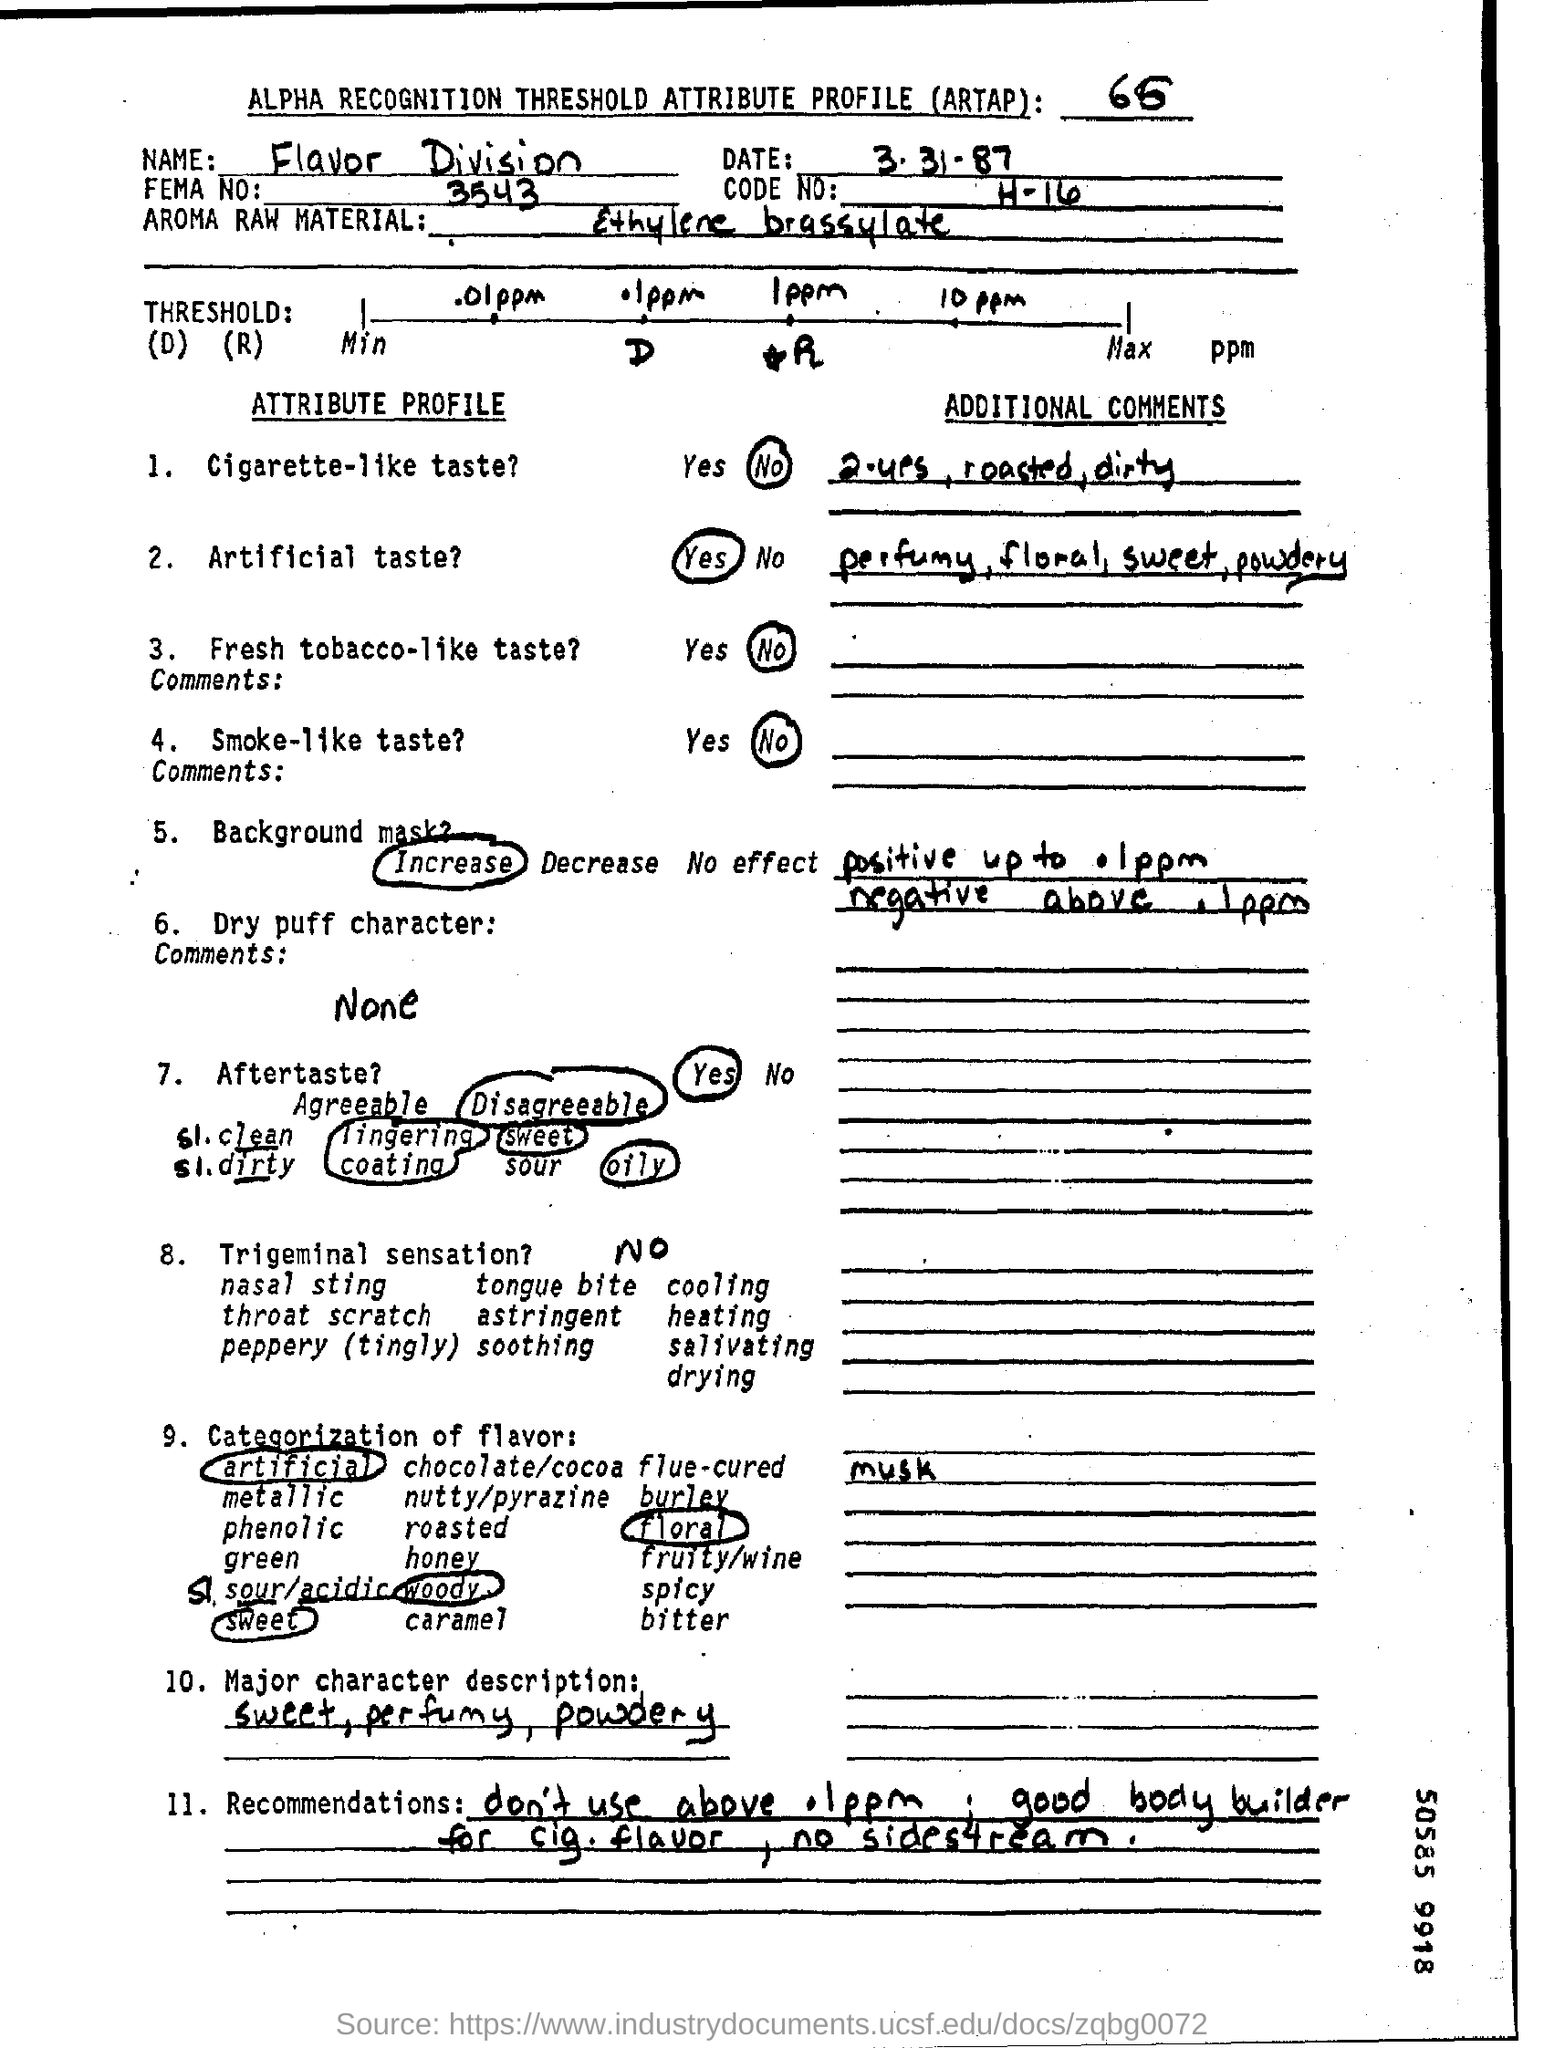List a handful of essential elements in this visual. The document mentions a name, which is 'flavor division.' The date mentioned is March 31st, 1987. 